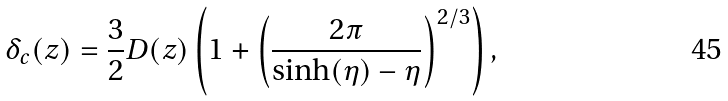<formula> <loc_0><loc_0><loc_500><loc_500>\delta _ { c } ( z ) = \frac { 3 } { 2 } D ( z ) \left ( 1 + \left ( \frac { 2 \pi } { \sinh ( \eta ) - \eta } \right ) ^ { 2 / 3 } \right ) ,</formula> 